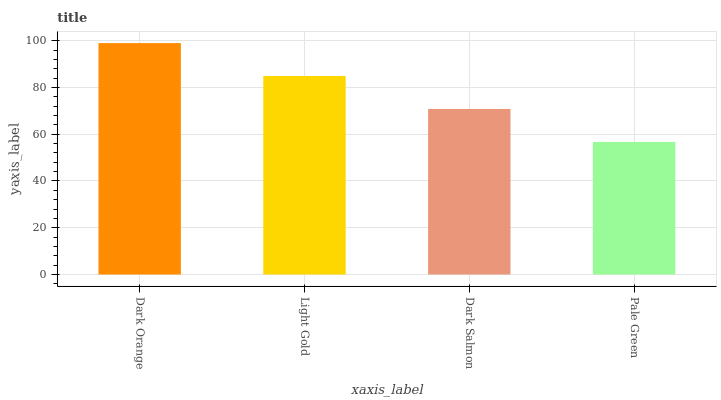Is Pale Green the minimum?
Answer yes or no. Yes. Is Dark Orange the maximum?
Answer yes or no. Yes. Is Light Gold the minimum?
Answer yes or no. No. Is Light Gold the maximum?
Answer yes or no. No. Is Dark Orange greater than Light Gold?
Answer yes or no. Yes. Is Light Gold less than Dark Orange?
Answer yes or no. Yes. Is Light Gold greater than Dark Orange?
Answer yes or no. No. Is Dark Orange less than Light Gold?
Answer yes or no. No. Is Light Gold the high median?
Answer yes or no. Yes. Is Dark Salmon the low median?
Answer yes or no. Yes. Is Pale Green the high median?
Answer yes or no. No. Is Dark Orange the low median?
Answer yes or no. No. 